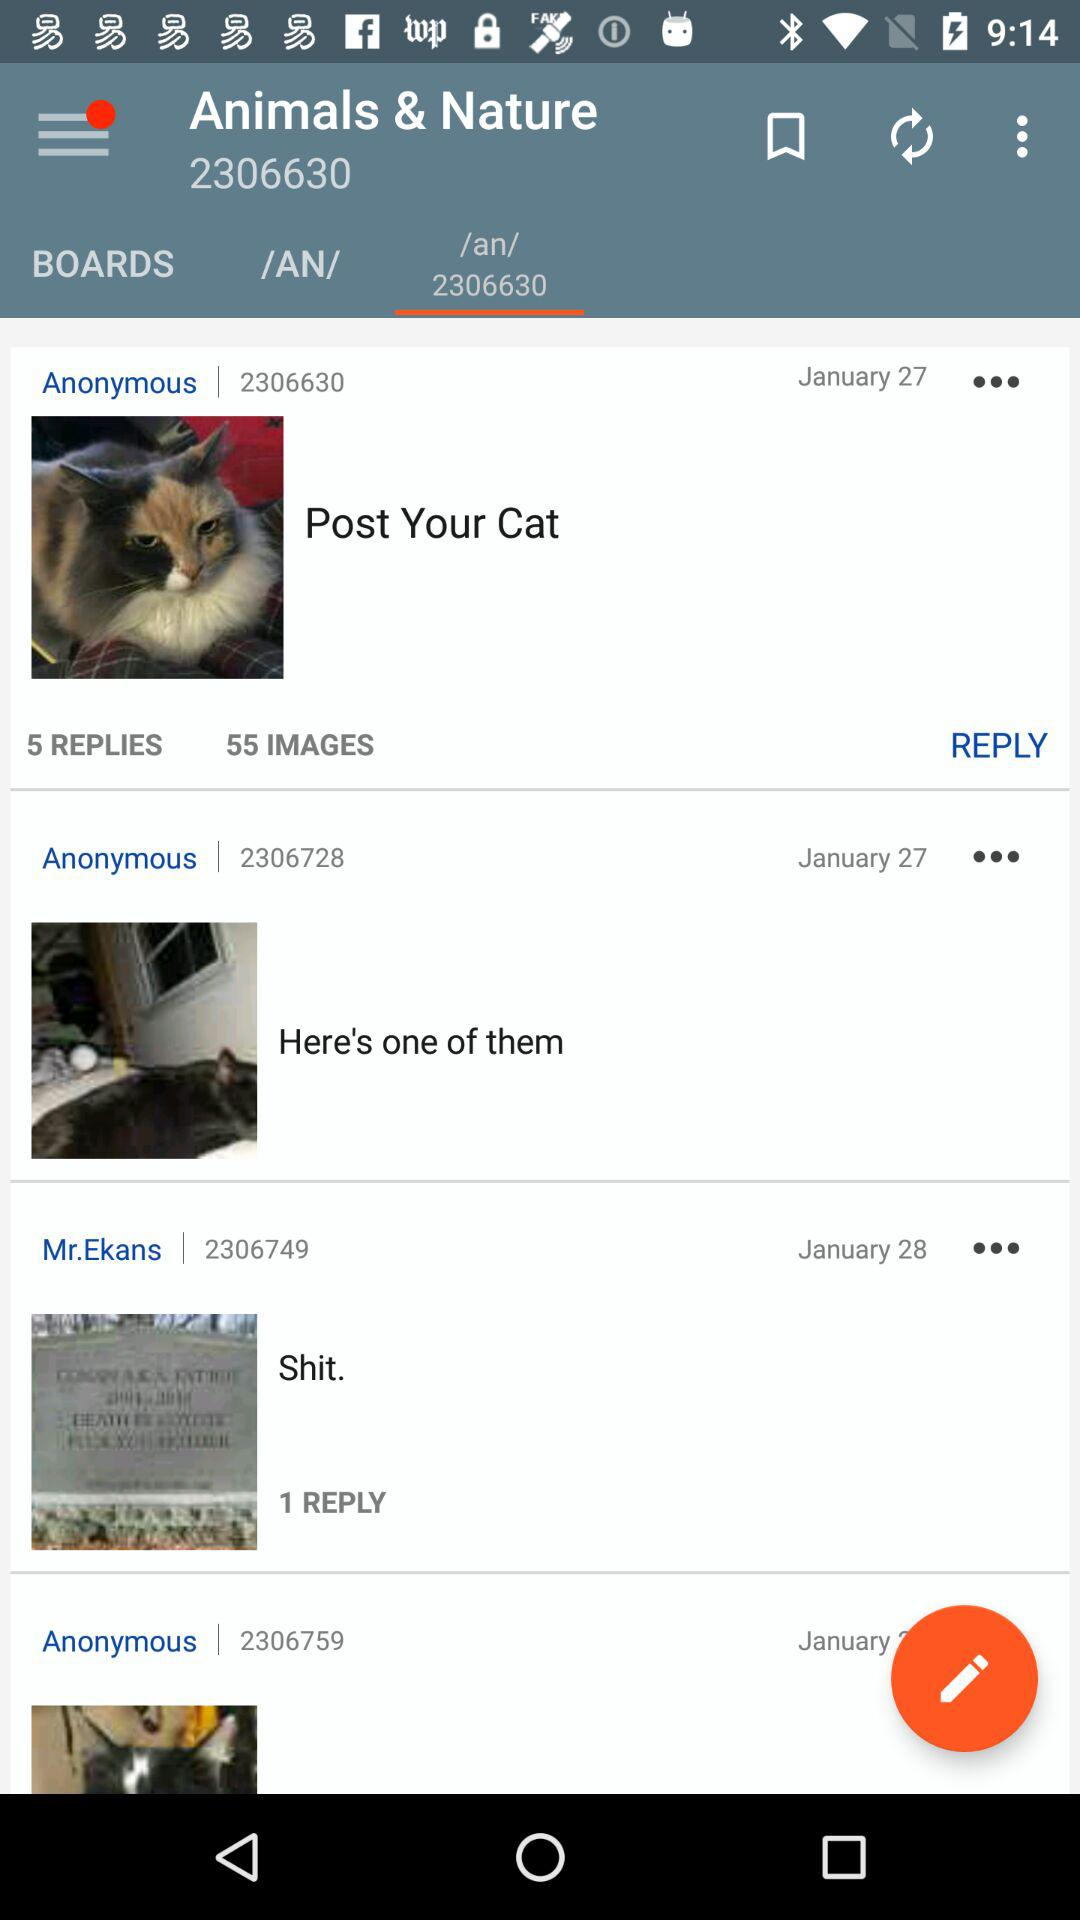Which user has the ID 2306749? The user is Mr. Ekans. 